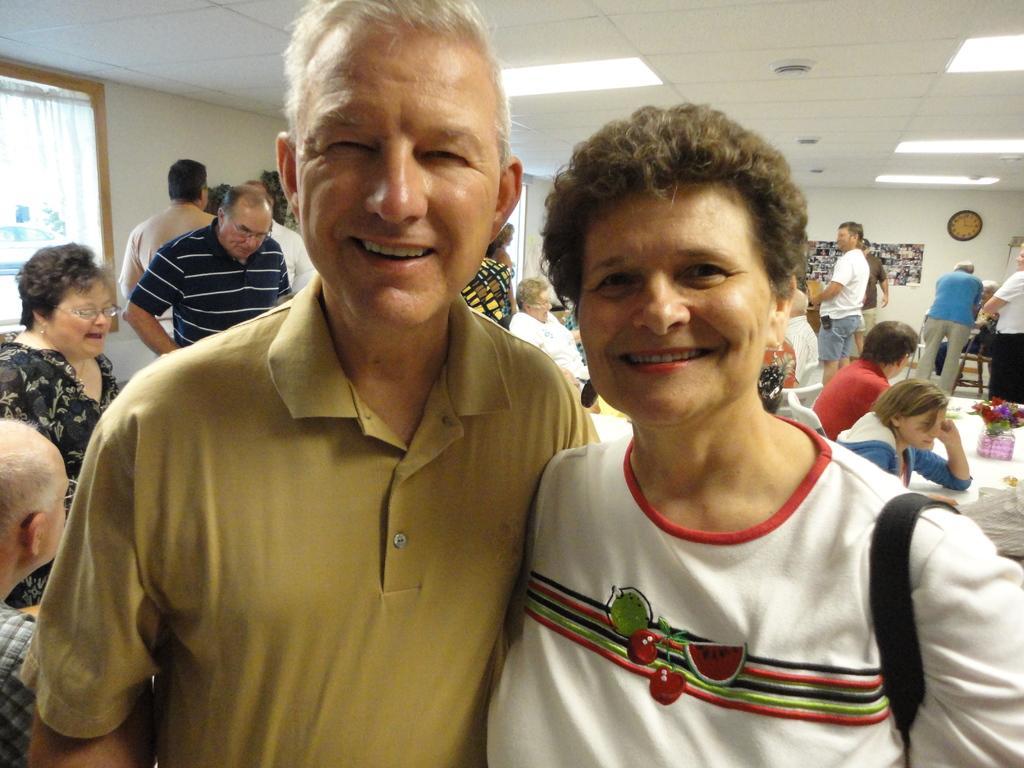Describe this image in one or two sentences. On the left side, there is a person in a t-shirt, smiling and standing. Beside him, there is a woman in white color t-shirt, smiling and standing. In the background, there are persons, there are lights attached to the roof and there is a window. 